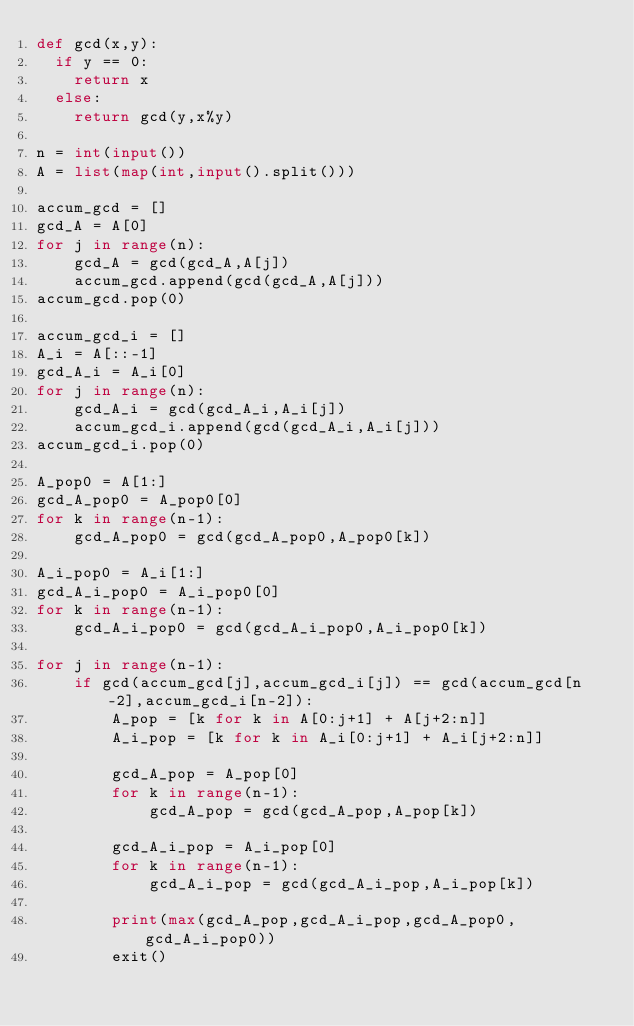Convert code to text. <code><loc_0><loc_0><loc_500><loc_500><_Python_>def gcd(x,y):
  if y == 0:
    return x
  else:
    return gcd(y,x%y)

n = int(input())
A = list(map(int,input().split()))

accum_gcd = []
gcd_A = A[0]
for j in range(n):
    gcd_A = gcd(gcd_A,A[j])
    accum_gcd.append(gcd(gcd_A,A[j]))
accum_gcd.pop(0)

accum_gcd_i = []
A_i = A[::-1]
gcd_A_i = A_i[0]
for j in range(n):
    gcd_A_i = gcd(gcd_A_i,A_i[j])
    accum_gcd_i.append(gcd(gcd_A_i,A_i[j]))
accum_gcd_i.pop(0)

A_pop0 = A[1:]
gcd_A_pop0 = A_pop0[0]
for k in range(n-1):
    gcd_A_pop0 = gcd(gcd_A_pop0,A_pop0[k])

A_i_pop0 = A_i[1:]
gcd_A_i_pop0 = A_i_pop0[0]
for k in range(n-1):
    gcd_A_i_pop0 = gcd(gcd_A_i_pop0,A_i_pop0[k])

for j in range(n-1):
    if gcd(accum_gcd[j],accum_gcd_i[j]) == gcd(accum_gcd[n-2],accum_gcd_i[n-2]):
        A_pop = [k for k in A[0:j+1] + A[j+2:n]]
        A_i_pop = [k for k in A_i[0:j+1] + A_i[j+2:n]]
        
        gcd_A_pop = A_pop[0]
        for k in range(n-1):
            gcd_A_pop = gcd(gcd_A_pop,A_pop[k])
            
        gcd_A_i_pop = A_i_pop[0]
        for k in range(n-1):
            gcd_A_i_pop = gcd(gcd_A_i_pop,A_i_pop[k])
        
        print(max(gcd_A_pop,gcd_A_i_pop,gcd_A_pop0,gcd_A_i_pop0))
        exit()</code> 